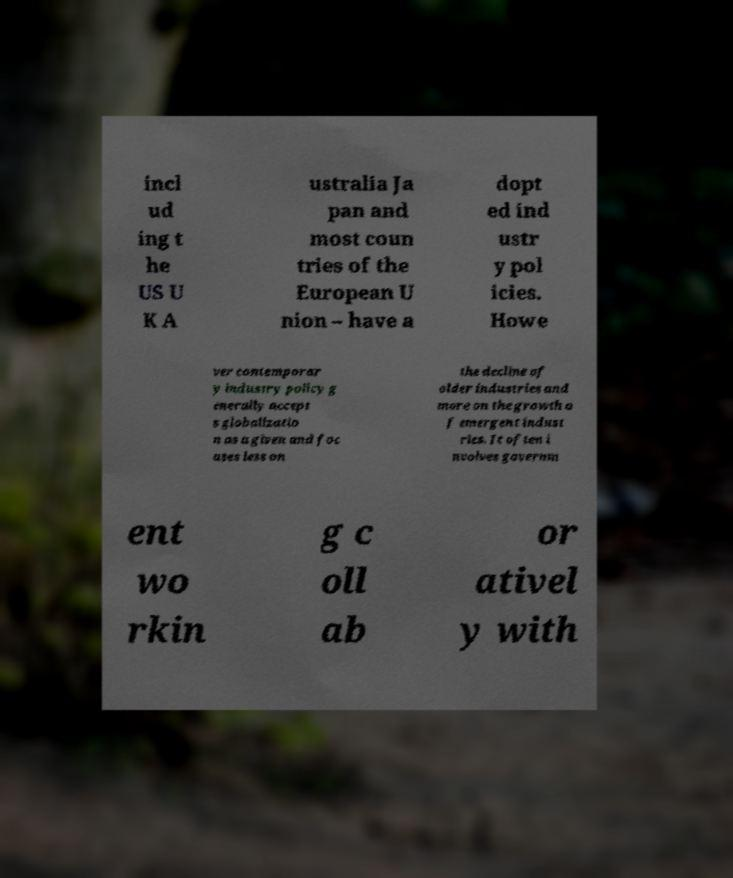Please read and relay the text visible in this image. What does it say? incl ud ing t he US U K A ustralia Ja pan and most coun tries of the European U nion – have a dopt ed ind ustr y pol icies. Howe ver contemporar y industry policy g enerally accept s globalizatio n as a given and foc uses less on the decline of older industries and more on the growth o f emergent indust ries. It often i nvolves governm ent wo rkin g c oll ab or ativel y with 